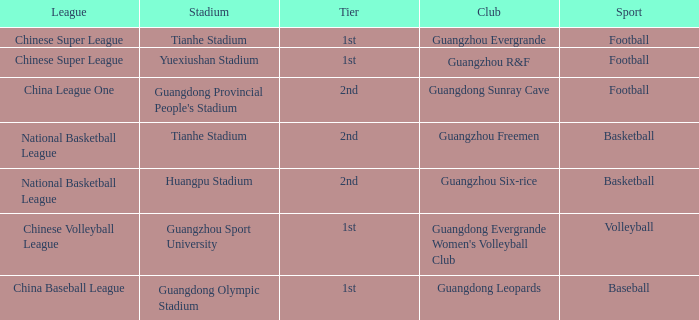Which stadium is for football with the China League One? Guangdong Provincial People's Stadium. 